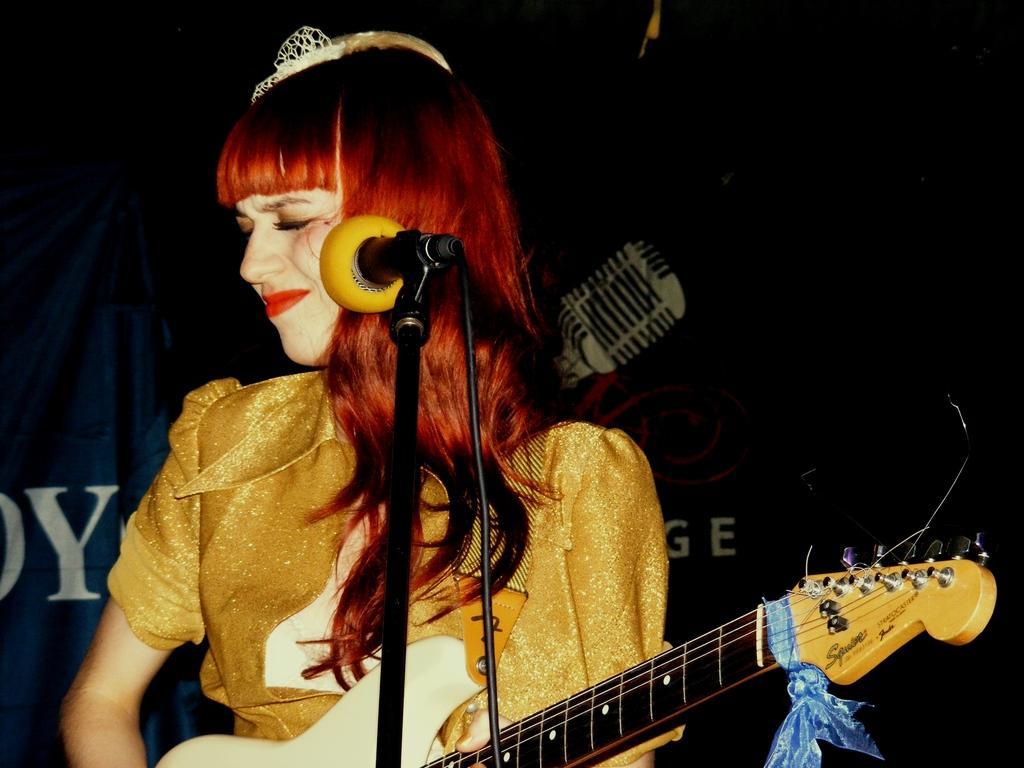How would you summarize this image in a sentence or two? Here in this picture we can see a woman present over a place and she is holding a guitar in her hand and in front of her we can see a microphone present and she is making a facial expression and behind her we can see a curtain present. 